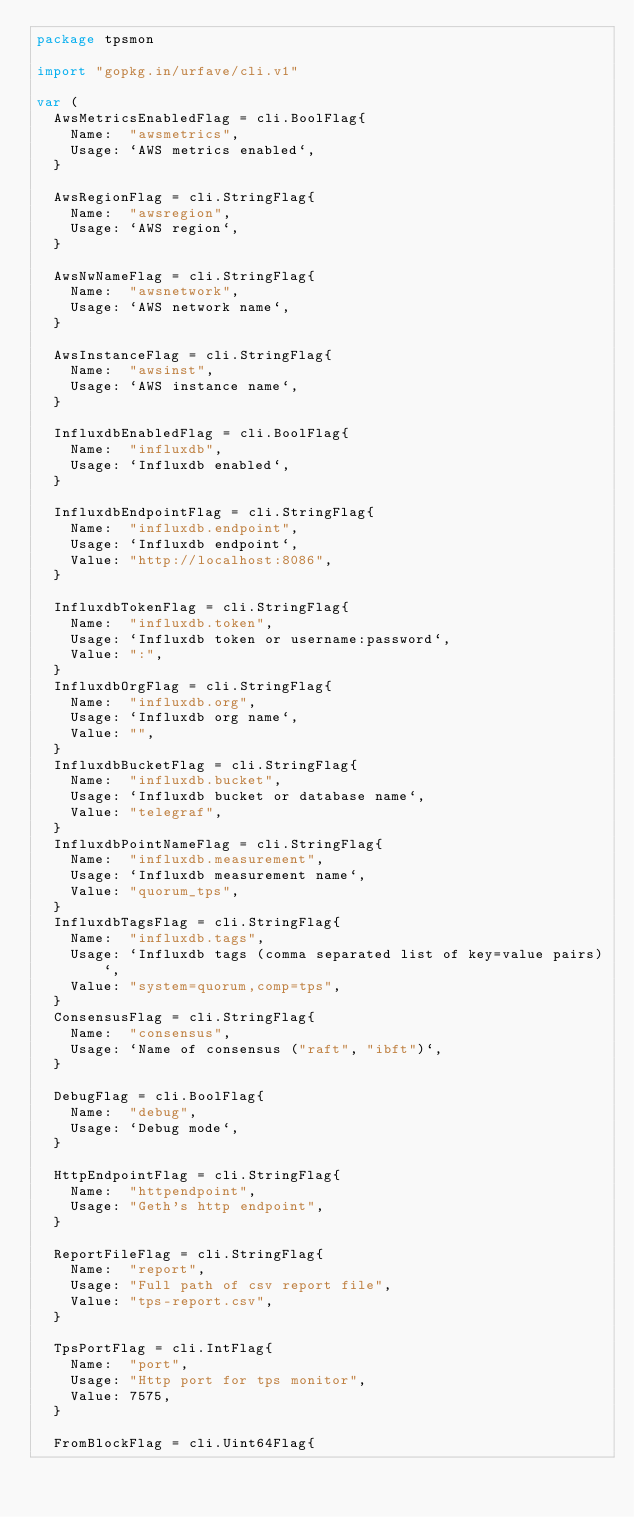Convert code to text. <code><loc_0><loc_0><loc_500><loc_500><_Go_>package tpsmon

import "gopkg.in/urfave/cli.v1"

var (
	AwsMetricsEnabledFlag = cli.BoolFlag{
		Name:  "awsmetrics",
		Usage: `AWS metrics enabled`,
	}

	AwsRegionFlag = cli.StringFlag{
		Name:  "awsregion",
		Usage: `AWS region`,
	}

	AwsNwNameFlag = cli.StringFlag{
		Name:  "awsnetwork",
		Usage: `AWS network name`,
	}

	AwsInstanceFlag = cli.StringFlag{
		Name:  "awsinst",
		Usage: `AWS instance name`,
	}

	InfluxdbEnabledFlag = cli.BoolFlag{
		Name:  "influxdb",
		Usage: `Influxdb enabled`,
	}

	InfluxdbEndpointFlag = cli.StringFlag{
		Name:  "influxdb.endpoint",
		Usage: `Influxdb endpoint`,
		Value: "http://localhost:8086",
	}

	InfluxdbTokenFlag = cli.StringFlag{
		Name:  "influxdb.token",
		Usage: `Influxdb token or username:password`,
		Value: ":",
	}
	InfluxdbOrgFlag = cli.StringFlag{
		Name:  "influxdb.org",
		Usage: `Influxdb org name`,
		Value: "",
	}
	InfluxdbBucketFlag = cli.StringFlag{
		Name:  "influxdb.bucket",
		Usage: `Influxdb bucket or database name`,
		Value: "telegraf",
	}
	InfluxdbPointNameFlag = cli.StringFlag{
		Name:  "influxdb.measurement",
		Usage: `Influxdb measurement name`,
		Value: "quorum_tps",
	}
	InfluxdbTagsFlag = cli.StringFlag{
		Name:  "influxdb.tags",
		Usage: `Influxdb tags (comma separated list of key=value pairs)`,
		Value: "system=quorum,comp=tps",
	}
	ConsensusFlag = cli.StringFlag{
		Name:  "consensus",
		Usage: `Name of consensus ("raft", "ibft")`,
	}

	DebugFlag = cli.BoolFlag{
		Name:  "debug",
		Usage: `Debug mode`,
	}

	HttpEndpointFlag = cli.StringFlag{
		Name:  "httpendpoint",
		Usage: "Geth's http endpoint",
	}

	ReportFileFlag = cli.StringFlag{
		Name:  "report",
		Usage: "Full path of csv report file",
		Value: "tps-report.csv",
	}

	TpsPortFlag = cli.IntFlag{
		Name:  "port",
		Usage: "Http port for tps monitor",
		Value: 7575,
	}

	FromBlockFlag = cli.Uint64Flag{</code> 